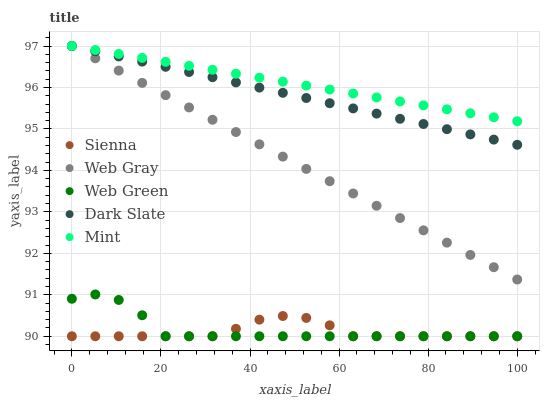Does Sienna have the minimum area under the curve?
Answer yes or no. Yes. Does Mint have the maximum area under the curve?
Answer yes or no. Yes. Does Dark Slate have the minimum area under the curve?
Answer yes or no. No. Does Dark Slate have the maximum area under the curve?
Answer yes or no. No. Is Mint the smoothest?
Answer yes or no. Yes. Is Web Green the roughest?
Answer yes or no. Yes. Is Dark Slate the smoothest?
Answer yes or no. No. Is Dark Slate the roughest?
Answer yes or no. No. Does Sienna have the lowest value?
Answer yes or no. Yes. Does Dark Slate have the lowest value?
Answer yes or no. No. Does Mint have the highest value?
Answer yes or no. Yes. Does Web Green have the highest value?
Answer yes or no. No. Is Sienna less than Web Gray?
Answer yes or no. Yes. Is Mint greater than Web Green?
Answer yes or no. Yes. Does Dark Slate intersect Web Gray?
Answer yes or no. Yes. Is Dark Slate less than Web Gray?
Answer yes or no. No. Is Dark Slate greater than Web Gray?
Answer yes or no. No. Does Sienna intersect Web Gray?
Answer yes or no. No. 